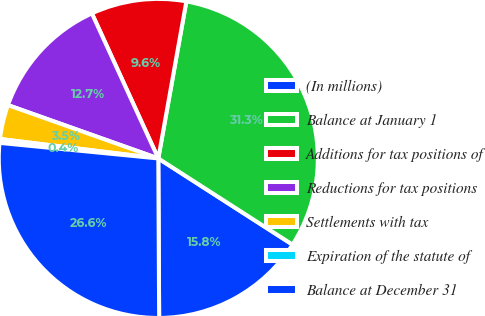Convert chart. <chart><loc_0><loc_0><loc_500><loc_500><pie_chart><fcel>(In millions)<fcel>Balance at January 1<fcel>Additions for tax positions of<fcel>Reductions for tax positions<fcel>Settlements with tax<fcel>Expiration of the statute of<fcel>Balance at December 31<nl><fcel>15.83%<fcel>31.27%<fcel>9.65%<fcel>12.74%<fcel>3.48%<fcel>0.39%<fcel>26.64%<nl></chart> 